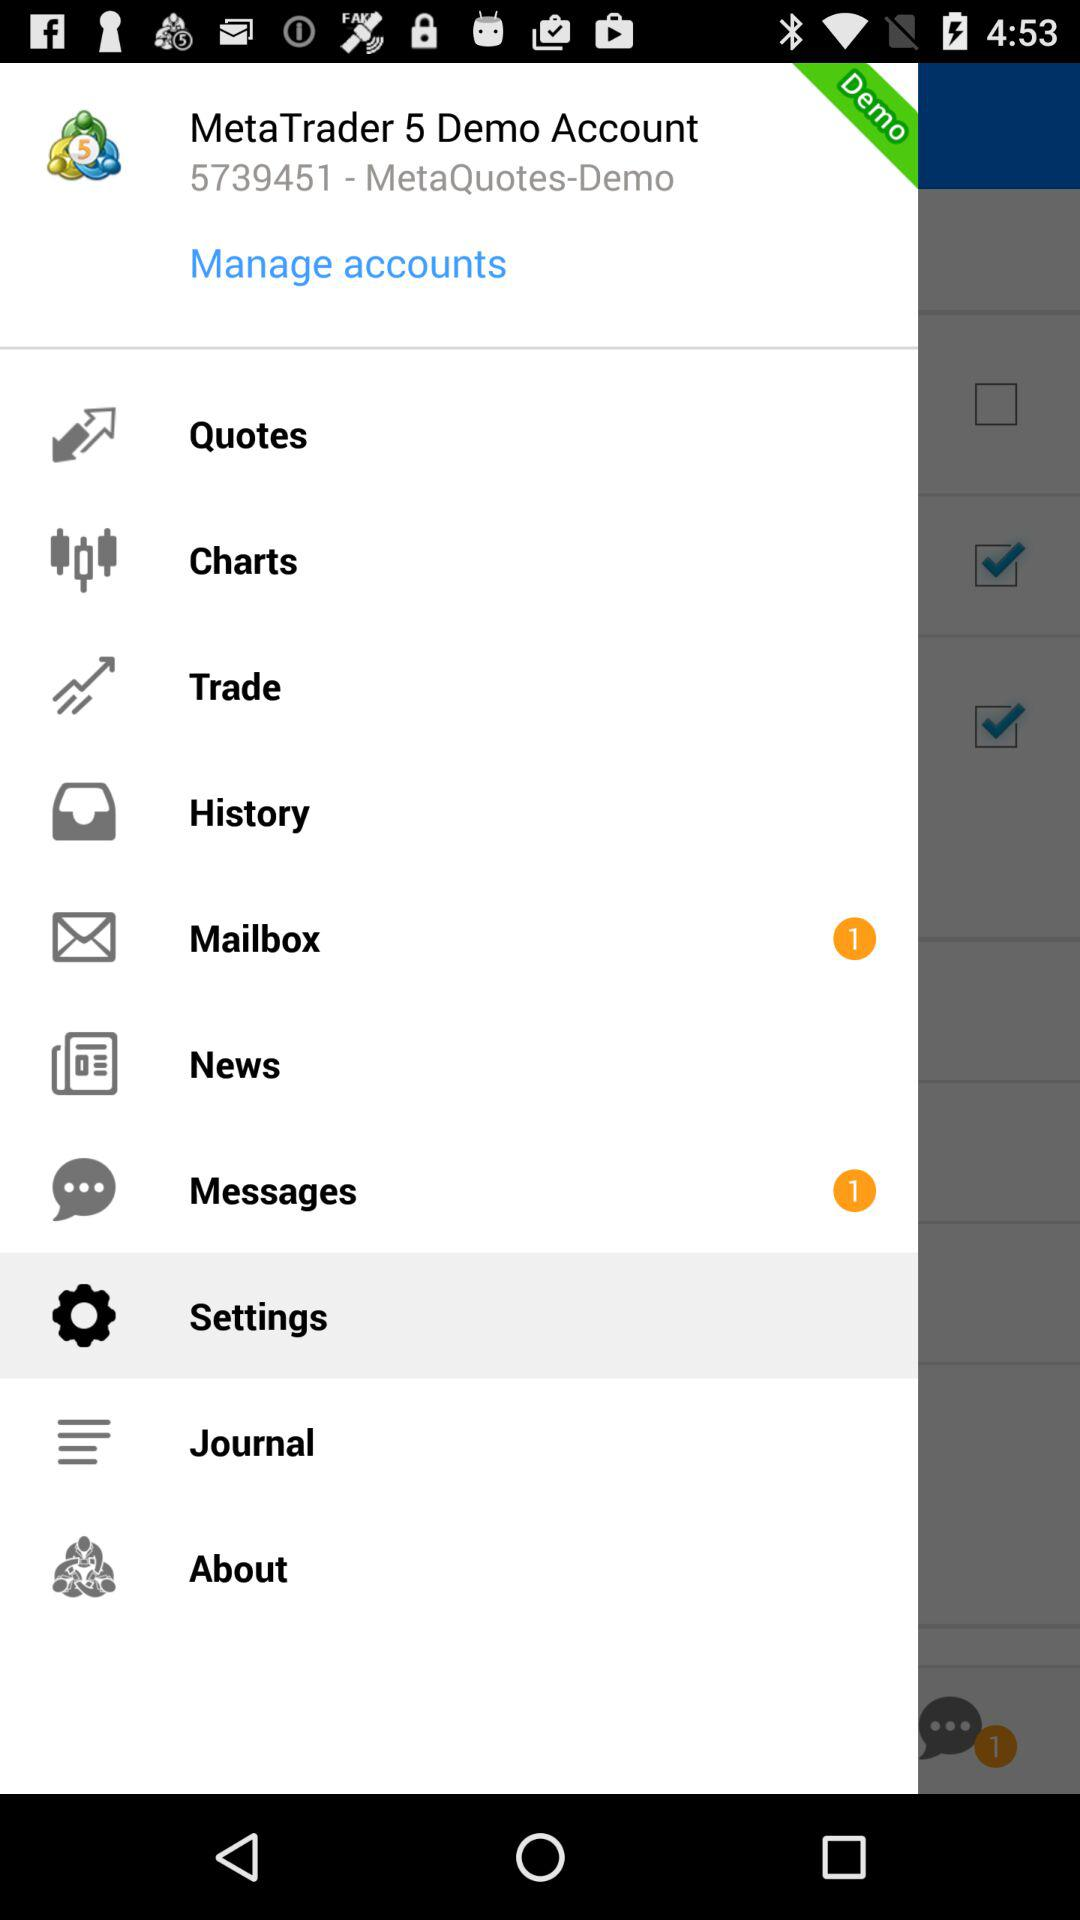Which item is selected? The selected item is "Settings". 